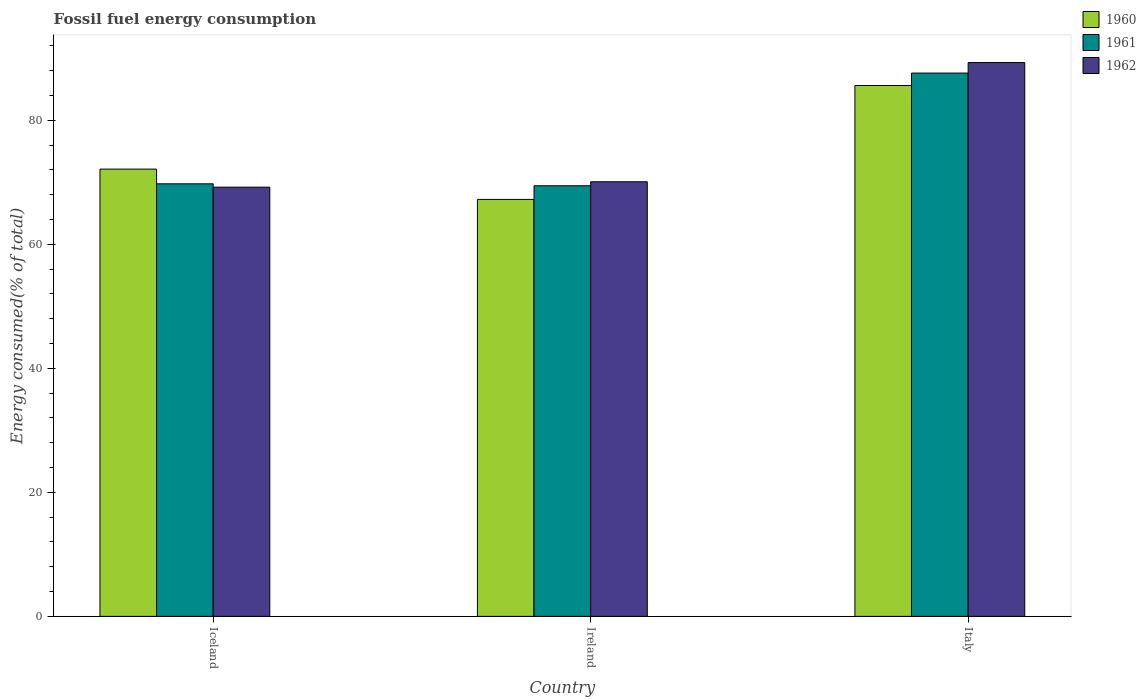How many different coloured bars are there?
Offer a very short reply. 3. How many groups of bars are there?
Your response must be concise. 3. Are the number of bars per tick equal to the number of legend labels?
Your answer should be compact. Yes. Are the number of bars on each tick of the X-axis equal?
Give a very brief answer. Yes. How many bars are there on the 3rd tick from the right?
Your answer should be compact. 3. What is the percentage of energy consumed in 1962 in Italy?
Ensure brevity in your answer.  89.31. Across all countries, what is the maximum percentage of energy consumed in 1962?
Offer a terse response. 89.31. Across all countries, what is the minimum percentage of energy consumed in 1961?
Provide a succinct answer. 69.44. In which country was the percentage of energy consumed in 1960 minimum?
Offer a very short reply. Ireland. What is the total percentage of energy consumed in 1962 in the graph?
Your response must be concise. 228.61. What is the difference between the percentage of energy consumed in 1961 in Iceland and that in Ireland?
Offer a very short reply. 0.32. What is the difference between the percentage of energy consumed in 1960 in Iceland and the percentage of energy consumed in 1962 in Ireland?
Make the answer very short. 2.04. What is the average percentage of energy consumed in 1962 per country?
Your response must be concise. 76.2. What is the difference between the percentage of energy consumed of/in 1962 and percentage of energy consumed of/in 1960 in Iceland?
Make the answer very short. -2.91. In how many countries, is the percentage of energy consumed in 1960 greater than 32 %?
Offer a terse response. 3. What is the ratio of the percentage of energy consumed in 1960 in Ireland to that in Italy?
Make the answer very short. 0.79. Is the percentage of energy consumed in 1960 in Iceland less than that in Ireland?
Your answer should be very brief. No. Is the difference between the percentage of energy consumed in 1962 in Ireland and Italy greater than the difference between the percentage of energy consumed in 1960 in Ireland and Italy?
Ensure brevity in your answer.  No. What is the difference between the highest and the second highest percentage of energy consumed in 1961?
Make the answer very short. -0.32. What is the difference between the highest and the lowest percentage of energy consumed in 1962?
Keep it short and to the point. 20.09. What does the 1st bar from the left in Iceland represents?
Ensure brevity in your answer.  1960. What does the 2nd bar from the right in Iceland represents?
Keep it short and to the point. 1961. How many countries are there in the graph?
Offer a very short reply. 3. What is the title of the graph?
Ensure brevity in your answer.  Fossil fuel energy consumption. What is the label or title of the Y-axis?
Your response must be concise. Energy consumed(% of total). What is the Energy consumed(% of total) in 1960 in Iceland?
Offer a very short reply. 72.13. What is the Energy consumed(% of total) in 1961 in Iceland?
Keep it short and to the point. 69.76. What is the Energy consumed(% of total) of 1962 in Iceland?
Offer a terse response. 69.22. What is the Energy consumed(% of total) in 1960 in Ireland?
Keep it short and to the point. 67.24. What is the Energy consumed(% of total) of 1961 in Ireland?
Offer a very short reply. 69.44. What is the Energy consumed(% of total) in 1962 in Ireland?
Give a very brief answer. 70.09. What is the Energy consumed(% of total) in 1960 in Italy?
Your answer should be very brief. 85.61. What is the Energy consumed(% of total) in 1961 in Italy?
Provide a succinct answer. 87.62. What is the Energy consumed(% of total) of 1962 in Italy?
Offer a terse response. 89.31. Across all countries, what is the maximum Energy consumed(% of total) of 1960?
Ensure brevity in your answer.  85.61. Across all countries, what is the maximum Energy consumed(% of total) of 1961?
Give a very brief answer. 87.62. Across all countries, what is the maximum Energy consumed(% of total) in 1962?
Your answer should be compact. 89.31. Across all countries, what is the minimum Energy consumed(% of total) of 1960?
Ensure brevity in your answer.  67.24. Across all countries, what is the minimum Energy consumed(% of total) in 1961?
Provide a succinct answer. 69.44. Across all countries, what is the minimum Energy consumed(% of total) in 1962?
Make the answer very short. 69.22. What is the total Energy consumed(% of total) in 1960 in the graph?
Keep it short and to the point. 224.98. What is the total Energy consumed(% of total) in 1961 in the graph?
Your answer should be very brief. 226.81. What is the total Energy consumed(% of total) of 1962 in the graph?
Your answer should be very brief. 228.61. What is the difference between the Energy consumed(% of total) of 1960 in Iceland and that in Ireland?
Provide a short and direct response. 4.89. What is the difference between the Energy consumed(% of total) in 1961 in Iceland and that in Ireland?
Give a very brief answer. 0.32. What is the difference between the Energy consumed(% of total) of 1962 in Iceland and that in Ireland?
Your answer should be very brief. -0.87. What is the difference between the Energy consumed(% of total) in 1960 in Iceland and that in Italy?
Provide a succinct answer. -13.48. What is the difference between the Energy consumed(% of total) of 1961 in Iceland and that in Italy?
Your answer should be very brief. -17.86. What is the difference between the Energy consumed(% of total) of 1962 in Iceland and that in Italy?
Make the answer very short. -20.09. What is the difference between the Energy consumed(% of total) of 1960 in Ireland and that in Italy?
Offer a very short reply. -18.37. What is the difference between the Energy consumed(% of total) of 1961 in Ireland and that in Italy?
Your response must be concise. -18.18. What is the difference between the Energy consumed(% of total) of 1962 in Ireland and that in Italy?
Keep it short and to the point. -19.23. What is the difference between the Energy consumed(% of total) of 1960 in Iceland and the Energy consumed(% of total) of 1961 in Ireland?
Keep it short and to the point. 2.69. What is the difference between the Energy consumed(% of total) of 1960 in Iceland and the Energy consumed(% of total) of 1962 in Ireland?
Ensure brevity in your answer.  2.04. What is the difference between the Energy consumed(% of total) in 1961 in Iceland and the Energy consumed(% of total) in 1962 in Ireland?
Make the answer very short. -0.33. What is the difference between the Energy consumed(% of total) in 1960 in Iceland and the Energy consumed(% of total) in 1961 in Italy?
Offer a terse response. -15.49. What is the difference between the Energy consumed(% of total) in 1960 in Iceland and the Energy consumed(% of total) in 1962 in Italy?
Offer a terse response. -17.18. What is the difference between the Energy consumed(% of total) of 1961 in Iceland and the Energy consumed(% of total) of 1962 in Italy?
Offer a terse response. -19.55. What is the difference between the Energy consumed(% of total) of 1960 in Ireland and the Energy consumed(% of total) of 1961 in Italy?
Your answer should be compact. -20.38. What is the difference between the Energy consumed(% of total) of 1960 in Ireland and the Energy consumed(% of total) of 1962 in Italy?
Provide a succinct answer. -22.07. What is the difference between the Energy consumed(% of total) of 1961 in Ireland and the Energy consumed(% of total) of 1962 in Italy?
Offer a very short reply. -19.87. What is the average Energy consumed(% of total) in 1960 per country?
Ensure brevity in your answer.  74.99. What is the average Energy consumed(% of total) of 1961 per country?
Make the answer very short. 75.6. What is the average Energy consumed(% of total) of 1962 per country?
Your answer should be compact. 76.2. What is the difference between the Energy consumed(% of total) in 1960 and Energy consumed(% of total) in 1961 in Iceland?
Make the answer very short. 2.37. What is the difference between the Energy consumed(% of total) in 1960 and Energy consumed(% of total) in 1962 in Iceland?
Provide a short and direct response. 2.91. What is the difference between the Energy consumed(% of total) of 1961 and Energy consumed(% of total) of 1962 in Iceland?
Offer a very short reply. 0.54. What is the difference between the Energy consumed(% of total) in 1960 and Energy consumed(% of total) in 1961 in Ireland?
Provide a short and direct response. -2.2. What is the difference between the Energy consumed(% of total) in 1960 and Energy consumed(% of total) in 1962 in Ireland?
Offer a very short reply. -2.84. What is the difference between the Energy consumed(% of total) in 1961 and Energy consumed(% of total) in 1962 in Ireland?
Your response must be concise. -0.65. What is the difference between the Energy consumed(% of total) of 1960 and Energy consumed(% of total) of 1961 in Italy?
Keep it short and to the point. -2.01. What is the difference between the Energy consumed(% of total) of 1960 and Energy consumed(% of total) of 1962 in Italy?
Make the answer very short. -3.7. What is the difference between the Energy consumed(% of total) in 1961 and Energy consumed(% of total) in 1962 in Italy?
Ensure brevity in your answer.  -1.69. What is the ratio of the Energy consumed(% of total) of 1960 in Iceland to that in Ireland?
Offer a very short reply. 1.07. What is the ratio of the Energy consumed(% of total) of 1961 in Iceland to that in Ireland?
Your answer should be very brief. 1. What is the ratio of the Energy consumed(% of total) of 1962 in Iceland to that in Ireland?
Give a very brief answer. 0.99. What is the ratio of the Energy consumed(% of total) of 1960 in Iceland to that in Italy?
Your response must be concise. 0.84. What is the ratio of the Energy consumed(% of total) of 1961 in Iceland to that in Italy?
Your answer should be compact. 0.8. What is the ratio of the Energy consumed(% of total) in 1962 in Iceland to that in Italy?
Give a very brief answer. 0.78. What is the ratio of the Energy consumed(% of total) of 1960 in Ireland to that in Italy?
Provide a succinct answer. 0.79. What is the ratio of the Energy consumed(% of total) of 1961 in Ireland to that in Italy?
Make the answer very short. 0.79. What is the ratio of the Energy consumed(% of total) of 1962 in Ireland to that in Italy?
Offer a terse response. 0.78. What is the difference between the highest and the second highest Energy consumed(% of total) in 1960?
Make the answer very short. 13.48. What is the difference between the highest and the second highest Energy consumed(% of total) of 1961?
Offer a very short reply. 17.86. What is the difference between the highest and the second highest Energy consumed(% of total) of 1962?
Your response must be concise. 19.23. What is the difference between the highest and the lowest Energy consumed(% of total) of 1960?
Your answer should be very brief. 18.37. What is the difference between the highest and the lowest Energy consumed(% of total) in 1961?
Give a very brief answer. 18.18. What is the difference between the highest and the lowest Energy consumed(% of total) of 1962?
Make the answer very short. 20.09. 